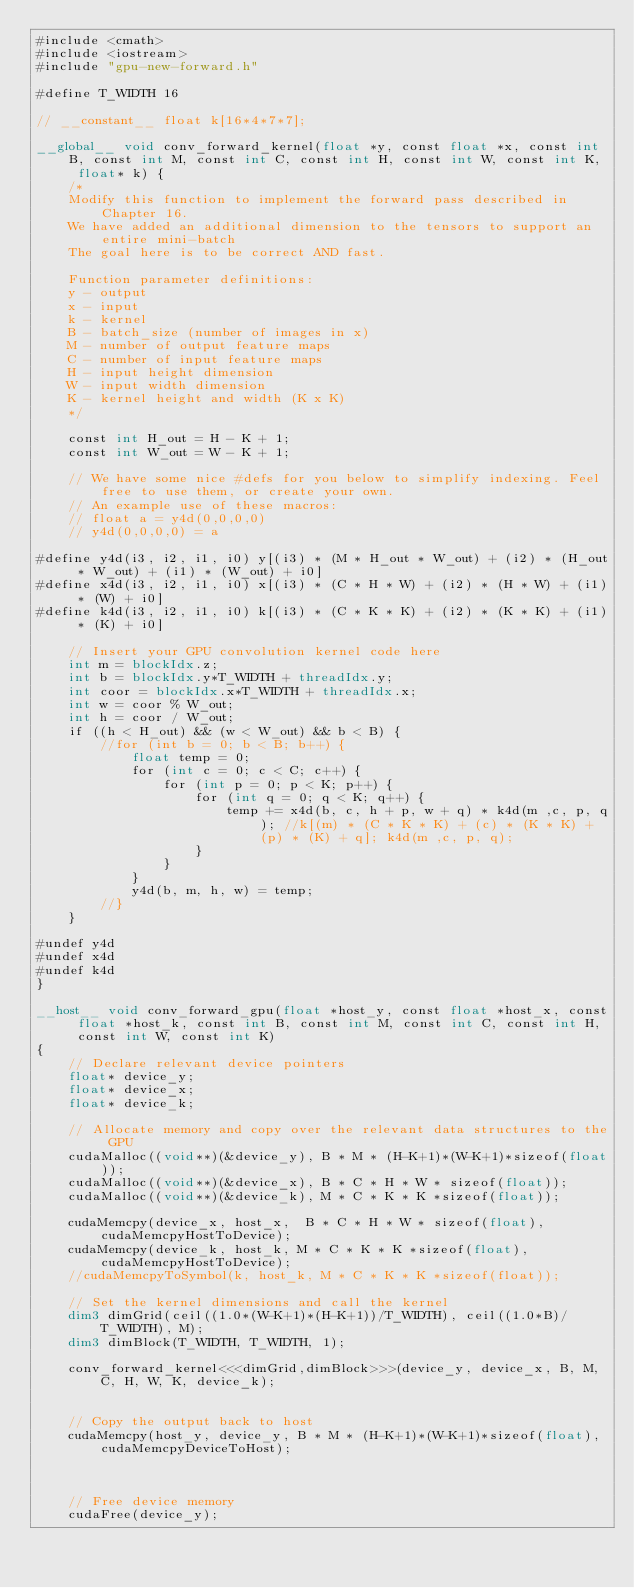Convert code to text. <code><loc_0><loc_0><loc_500><loc_500><_Cuda_>#include <cmath>
#include <iostream>
#include "gpu-new-forward.h"

#define T_WIDTH 16

// __constant__ float k[16*4*7*7];

__global__ void conv_forward_kernel(float *y, const float *x, const int B, const int M, const int C, const int H, const int W, const int K, float* k) {
    /*
    Modify this function to implement the forward pass described in Chapter 16.
    We have added an additional dimension to the tensors to support an entire mini-batch
    The goal here is to be correct AND fast.

    Function parameter definitions:
    y - output
    x - input
    k - kernel
    B - batch_size (number of images in x)
    M - number of output feature maps
    C - number of input feature maps
    H - input height dimension
    W - input width dimension
    K - kernel height and width (K x K)
    */

    const int H_out = H - K + 1;
    const int W_out = W - K + 1;

    // We have some nice #defs for you below to simplify indexing. Feel free to use them, or create your own.
    // An example use of these macros:
    // float a = y4d(0,0,0,0)
    // y4d(0,0,0,0) = a

#define y4d(i3, i2, i1, i0) y[(i3) * (M * H_out * W_out) + (i2) * (H_out * W_out) + (i1) * (W_out) + i0]
#define x4d(i3, i2, i1, i0) x[(i3) * (C * H * W) + (i2) * (H * W) + (i1) * (W) + i0]
#define k4d(i3, i2, i1, i0) k[(i3) * (C * K * K) + (i2) * (K * K) + (i1) * (K) + i0]

    // Insert your GPU convolution kernel code here
    int m = blockIdx.z;
    int b = blockIdx.y*T_WIDTH + threadIdx.y;
    int coor = blockIdx.x*T_WIDTH + threadIdx.x;
    int w = coor % W_out;
    int h = coor / W_out;
    if ((h < H_out) && (w < W_out) && b < B) {
        //for (int b = 0; b < B; b++) {
            float temp = 0;
            for (int c = 0; c < C; c++) {
                for (int p = 0; p < K; p++) {
                    for (int q = 0; q < K; q++) {
                        temp += x4d(b, c, h + p, w + q) * k4d(m ,c, p, q); //k[(m) * (C * K * K) + (c) * (K * K) + (p) * (K) + q]; k4d(m ,c, p, q);
                    }
                }
            }
            y4d(b, m, h, w) = temp;
        //}
    }

#undef y4d
#undef x4d
#undef k4d
}

__host__ void conv_forward_gpu(float *host_y, const float *host_x, const float *host_k, const int B, const int M, const int C, const int H, const int W, const int K)
{
    // Declare relevant device pointers
    float* device_y;
    float* device_x;
    float* device_k;

    // Allocate memory and copy over the relevant data structures to the GPU
    cudaMalloc((void**)(&device_y), B * M * (H-K+1)*(W-K+1)*sizeof(float));
    cudaMalloc((void**)(&device_x), B * C * H * W * sizeof(float));
    cudaMalloc((void**)(&device_k), M * C * K * K *sizeof(float));

    cudaMemcpy(device_x, host_x,  B * C * H * W * sizeof(float), cudaMemcpyHostToDevice);
    cudaMemcpy(device_k, host_k, M * C * K * K *sizeof(float), cudaMemcpyHostToDevice);
    //cudaMemcpyToSymbol(k, host_k, M * C * K * K *sizeof(float));

    // Set the kernel dimensions and call the kernel
    dim3 dimGrid(ceil((1.0*(W-K+1)*(H-K+1))/T_WIDTH), ceil((1.0*B)/T_WIDTH), M);
    dim3 dimBlock(T_WIDTH, T_WIDTH, 1);

    conv_forward_kernel<<<dimGrid,dimBlock>>>(device_y, device_x, B, M, C, H, W, K, device_k);


    // Copy the output back to host
    cudaMemcpy(host_y, device_y, B * M * (H-K+1)*(W-K+1)*sizeof(float), cudaMemcpyDeviceToHost);
    


    // Free device memory
    cudaFree(device_y);</code> 